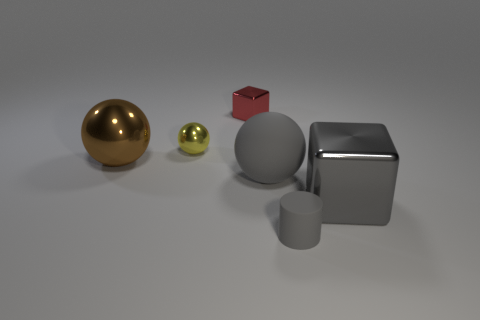Are there any other things that are the same shape as the tiny gray matte object?
Your answer should be compact. No. What number of matte objects are either gray spheres or tiny cyan cubes?
Make the answer very short. 1. There is a metal cube that is in front of the yellow shiny object; are there any small gray rubber cylinders in front of it?
Your answer should be compact. Yes. Is the cube that is behind the large brown metal object made of the same material as the big block?
Give a very brief answer. Yes. What number of other objects are the same color as the large matte sphere?
Offer a terse response. 2. Do the tiny rubber cylinder and the large matte ball have the same color?
Make the answer very short. Yes. There is a cube in front of the brown metal object that is to the left of the big gray matte object; how big is it?
Make the answer very short. Large. Is the material of the block that is to the right of the rubber cylinder the same as the large object that is to the left of the tiny red thing?
Ensure brevity in your answer.  Yes. There is a big sphere in front of the brown ball; does it have the same color as the large cube?
Make the answer very short. Yes. What number of metal spheres are in front of the yellow metal thing?
Ensure brevity in your answer.  1. 